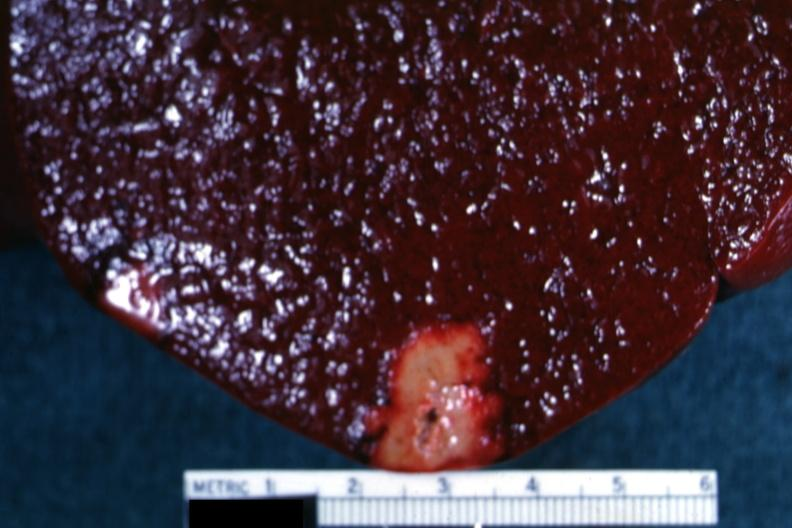what is present?
Answer the question using a single word or phrase. Hematologic 